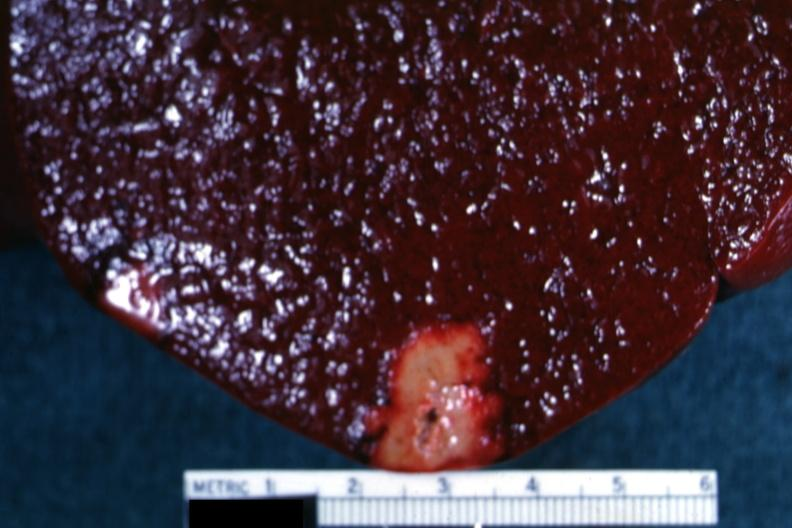what is present?
Answer the question using a single word or phrase. Hematologic 